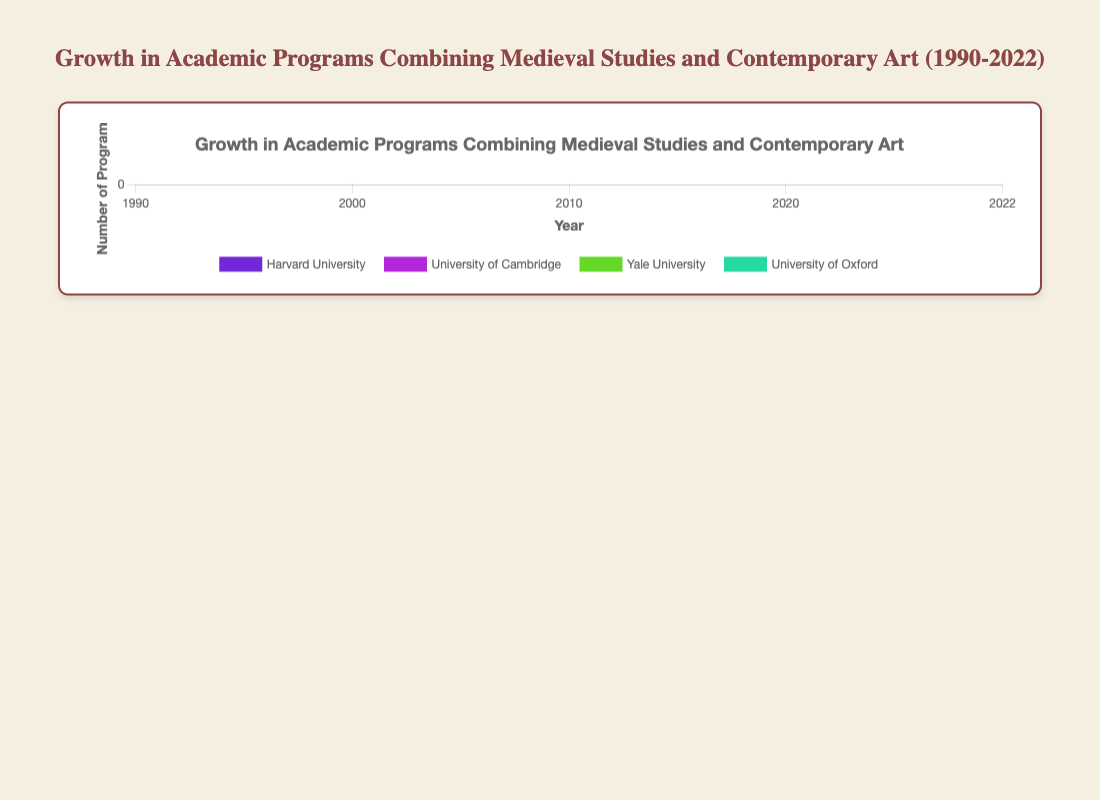Which university had the highest growth in the number of programs between 1990 and 2022? To determine this, calculate the difference in the number of programs between 1990 and 2022 for each university and identify the one with the largest increase. Harvard University grew from 1 program in 1990 to 8 programs in 2022, which is an increase of 7 programs.
Answer: Harvard University Which two universities had the same number of programs in 2022? In 2022, both the University of Cambridge and the University of Oxford have 6 programs. Compare the number of programs for all universities in 2022 to find this match.
Answer: University of Cambridge and University of Oxford What is the average number of programs for Harvard University from 1990 to 2022? Calculate the sum of the programs for Harvard University over the years (1 + 2 + 4 + 7 + 8 = 22), then divide by the number of data points (5 years). The average is 22/5.
Answer: 4.4 How much more did Harvard University increase its number of programs from 2000 to 2020 compared to Yale University in the same period? Harvard University increased from 2 programs in 2000 to 7 programs in 2020, a difference of 5. Yale University increased from 1 to 4, a difference of 3. Harvard's increase (5) minus Yale's increase (3) gives the additional increase.
Answer: 2 Which university showed no growth between 1990 and 2000? Look for universities where the number of programs remained the same between 1990 and 2000. The University of Cambridge and the University of Oxford both had 1 program in 1990 and 1 in 2000.
Answer: University of Cambridge and University of Oxford In which year did the University of California, Berkeley first introduce a program combining Medieval Studies and Contemporary Art? Examine the years and number of programs to identify when University of California, Berkeley first has more than 0 programs. This university had 1 program starting in the year 2010.
Answer: 2010 By how much did the sum of programs for all universities increase from 2010 to 2022? Add the total number of programs for all universities in 2010 and 2022, then find the difference. In 2010, the total number is 15 (1+3+2+3+1+2), and in 2022, it is 34 (8+6+5+6+4+5). The increase is 34 - 15.
Answer: 19 Which university had the least number of programs in 1990 and how many did it have? Review the number of programs each university had in 1990 and identify the minimum value. Yale University and University of California, Berkeley had 0 programs that year.
Answer: Yale University and University of California, Berkeley What is the trend in the number of programs for Stanford University from 1990 to 2022? Observe the changes in the number of programs for Stanford University over the years: 0 in 1990, 1 in 2000, 2 in 2010, 3 in 2020, and 5 in 2022, indicating a consistent growth.
Answer: Consistent growth 